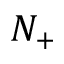Convert formula to latex. <formula><loc_0><loc_0><loc_500><loc_500>N _ { + }</formula> 